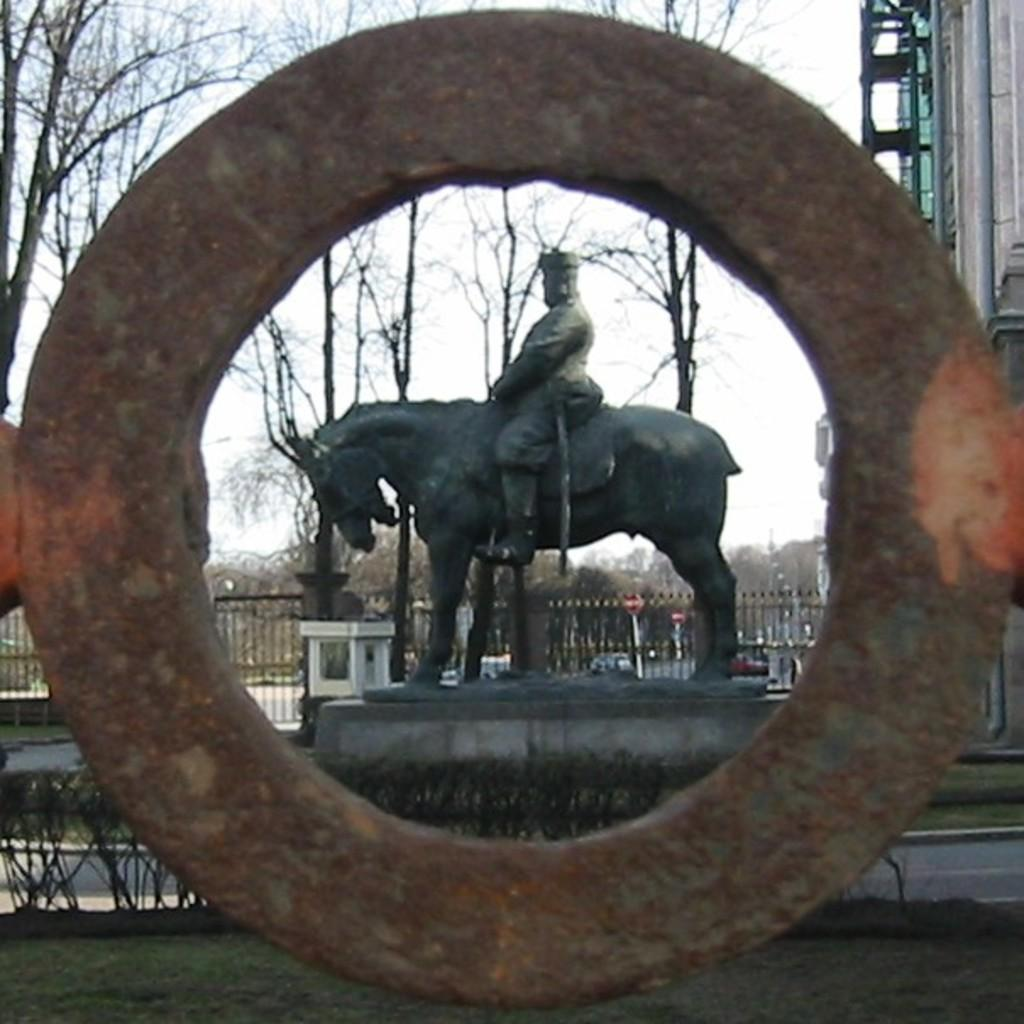What is the main object in the image? There is a ring in the image. What other objects can be seen in the image? There is a sculpture, a fence, trees, grass, and plants visible in the image. What type of vegetation is present in the image? There are trees, grass, and plants in the image. What can be seen in the background of the image? The sky is visible in the background of the image. How does the clover stretch in the image? There is no clover present in the image, so it cannot be stretched. 